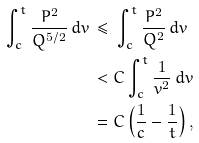Convert formula to latex. <formula><loc_0><loc_0><loc_500><loc_500>\int _ { c } ^ { t } \frac { P ^ { 2 } } { Q ^ { 5 / 2 } } \, d v \, & \leq \, \int _ { c } ^ { t } \frac { P ^ { 2 } } { Q ^ { 2 } } \, d v \\ & < C \int _ { c } ^ { t } \frac { 1 } { v ^ { 2 } } \, d v \\ & = C \left ( \frac { 1 } { c } - \frac { 1 } { t } \right ) ,</formula> 